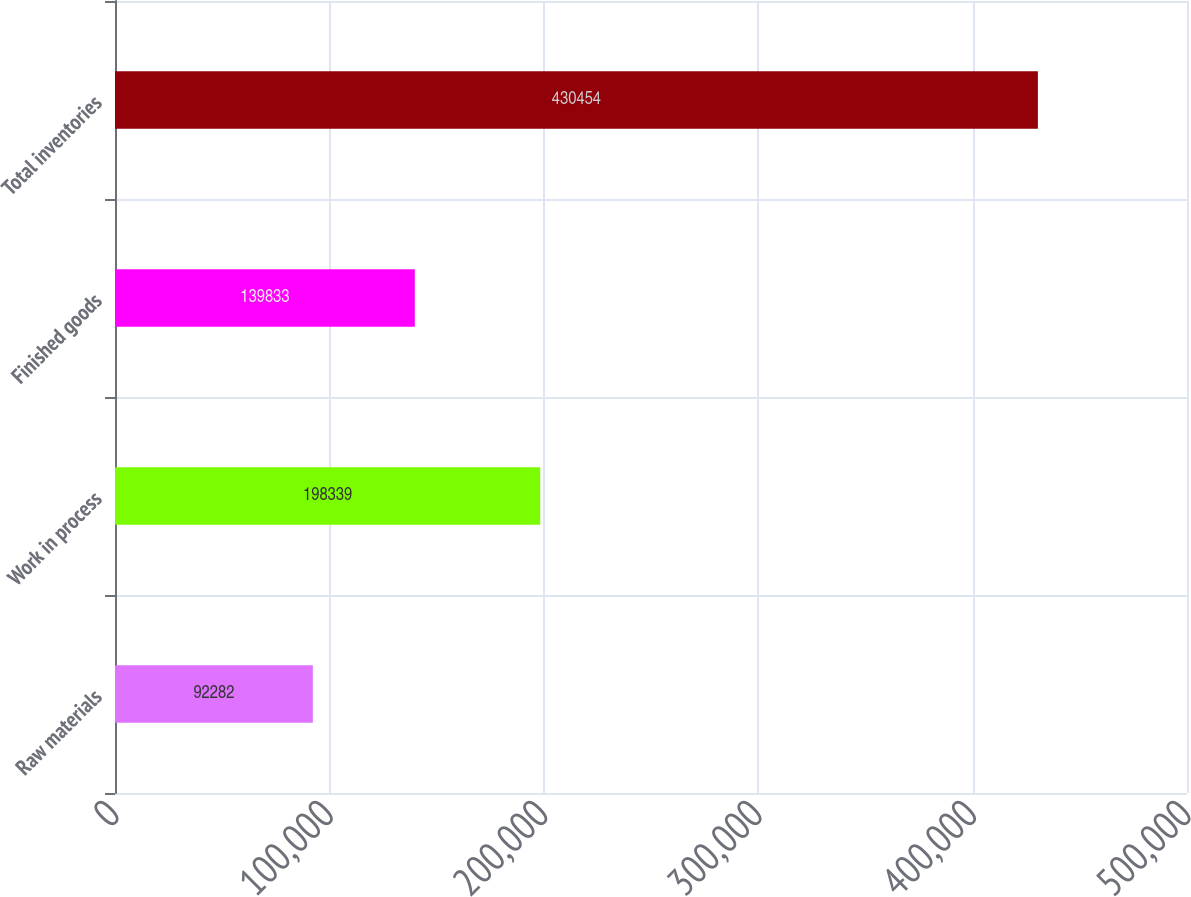Convert chart. <chart><loc_0><loc_0><loc_500><loc_500><bar_chart><fcel>Raw materials<fcel>Work in process<fcel>Finished goods<fcel>Total inventories<nl><fcel>92282<fcel>198339<fcel>139833<fcel>430454<nl></chart> 